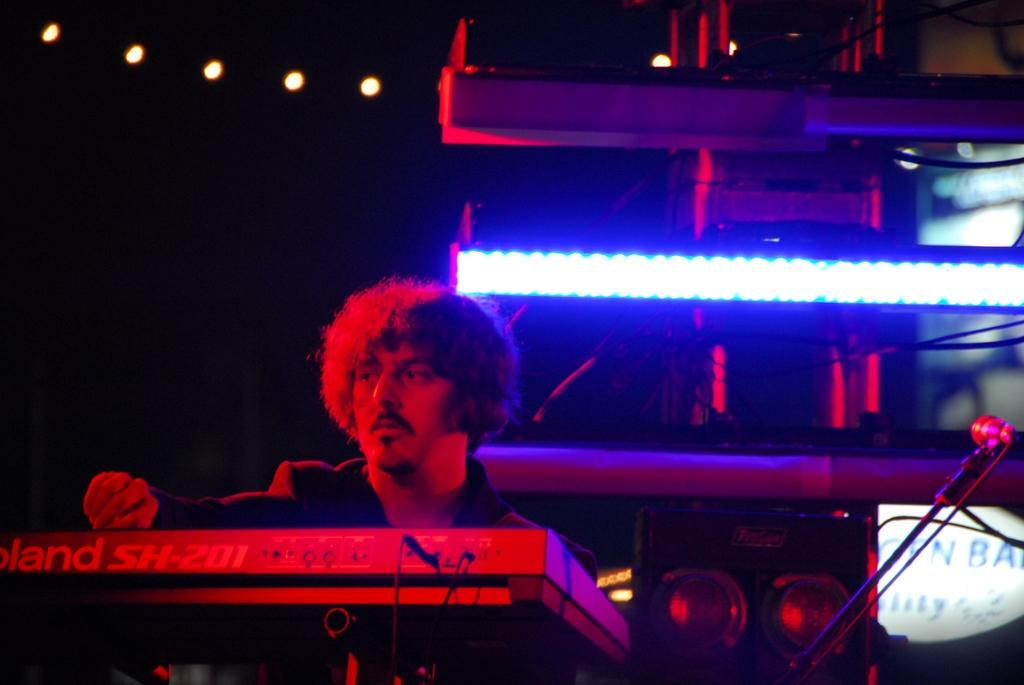What is the main object in the image? There is a mic with a holder in the image. What other equipment can be seen in the image? There are speakers and focusing lights visible in the image. What is the man in the image doing? The man is playing a musical instrument in front of him. What type of berry is being used as a prop in the image? There is no berry present in the image. How does the yak contribute to the musical performance in the image? There is no yak present in the image, so it cannot contribute to the musical performance. 